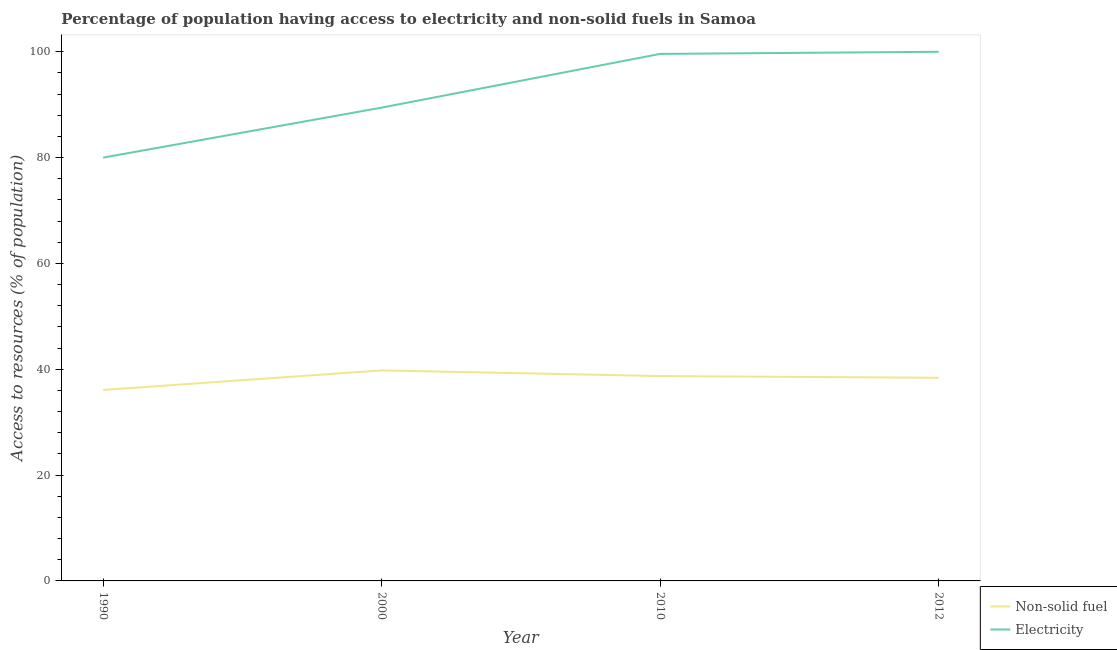Is the number of lines equal to the number of legend labels?
Offer a terse response. Yes. What is the percentage of population having access to non-solid fuel in 2012?
Provide a succinct answer. 38.39. Across all years, what is the maximum percentage of population having access to non-solid fuel?
Give a very brief answer. 39.78. Across all years, what is the minimum percentage of population having access to non-solid fuel?
Offer a very short reply. 36.09. In which year was the percentage of population having access to electricity maximum?
Provide a short and direct response. 2012. What is the total percentage of population having access to non-solid fuel in the graph?
Your answer should be compact. 152.99. What is the difference between the percentage of population having access to electricity in 1990 and that in 2000?
Your response must be concise. -9.45. What is the difference between the percentage of population having access to non-solid fuel in 2010 and the percentage of population having access to electricity in 2000?
Your response must be concise. -50.73. What is the average percentage of population having access to non-solid fuel per year?
Give a very brief answer. 38.25. In the year 2000, what is the difference between the percentage of population having access to non-solid fuel and percentage of population having access to electricity?
Keep it short and to the point. -49.66. In how many years, is the percentage of population having access to electricity greater than 92 %?
Ensure brevity in your answer.  2. What is the ratio of the percentage of population having access to non-solid fuel in 2010 to that in 2012?
Provide a succinct answer. 1.01. Is the percentage of population having access to electricity in 1990 less than that in 2012?
Offer a very short reply. Yes. Is the difference between the percentage of population having access to electricity in 2000 and 2012 greater than the difference between the percentage of population having access to non-solid fuel in 2000 and 2012?
Provide a short and direct response. No. What is the difference between the highest and the second highest percentage of population having access to non-solid fuel?
Make the answer very short. 1.07. What is the difference between the highest and the lowest percentage of population having access to non-solid fuel?
Offer a very short reply. 3.69. Is the sum of the percentage of population having access to electricity in 1990 and 2000 greater than the maximum percentage of population having access to non-solid fuel across all years?
Ensure brevity in your answer.  Yes. Is the percentage of population having access to electricity strictly greater than the percentage of population having access to non-solid fuel over the years?
Keep it short and to the point. Yes. Is the percentage of population having access to non-solid fuel strictly less than the percentage of population having access to electricity over the years?
Your answer should be compact. Yes. How many lines are there?
Your response must be concise. 2. How many years are there in the graph?
Give a very brief answer. 4. What is the difference between two consecutive major ticks on the Y-axis?
Your response must be concise. 20. Are the values on the major ticks of Y-axis written in scientific E-notation?
Offer a very short reply. No. Does the graph contain any zero values?
Give a very brief answer. No. Does the graph contain grids?
Your response must be concise. No. Where does the legend appear in the graph?
Your answer should be very brief. Bottom right. How many legend labels are there?
Provide a succinct answer. 2. What is the title of the graph?
Your response must be concise. Percentage of population having access to electricity and non-solid fuels in Samoa. What is the label or title of the Y-axis?
Your answer should be very brief. Access to resources (% of population). What is the Access to resources (% of population) in Non-solid fuel in 1990?
Provide a succinct answer. 36.09. What is the Access to resources (% of population) in Electricity in 1990?
Give a very brief answer. 80. What is the Access to resources (% of population) in Non-solid fuel in 2000?
Your response must be concise. 39.78. What is the Access to resources (% of population) in Electricity in 2000?
Your response must be concise. 89.45. What is the Access to resources (% of population) in Non-solid fuel in 2010?
Keep it short and to the point. 38.72. What is the Access to resources (% of population) of Electricity in 2010?
Offer a terse response. 99.6. What is the Access to resources (% of population) of Non-solid fuel in 2012?
Provide a succinct answer. 38.39. What is the Access to resources (% of population) in Electricity in 2012?
Give a very brief answer. 100. Across all years, what is the maximum Access to resources (% of population) of Non-solid fuel?
Give a very brief answer. 39.78. Across all years, what is the maximum Access to resources (% of population) of Electricity?
Give a very brief answer. 100. Across all years, what is the minimum Access to resources (% of population) of Non-solid fuel?
Make the answer very short. 36.09. What is the total Access to resources (% of population) of Non-solid fuel in the graph?
Ensure brevity in your answer.  152.99. What is the total Access to resources (% of population) of Electricity in the graph?
Provide a succinct answer. 369.05. What is the difference between the Access to resources (% of population) in Non-solid fuel in 1990 and that in 2000?
Your answer should be very brief. -3.69. What is the difference between the Access to resources (% of population) of Electricity in 1990 and that in 2000?
Your answer should be very brief. -9.45. What is the difference between the Access to resources (% of population) of Non-solid fuel in 1990 and that in 2010?
Make the answer very short. -2.62. What is the difference between the Access to resources (% of population) of Electricity in 1990 and that in 2010?
Offer a very short reply. -19.6. What is the difference between the Access to resources (% of population) in Non-solid fuel in 1990 and that in 2012?
Your answer should be very brief. -2.3. What is the difference between the Access to resources (% of population) in Non-solid fuel in 2000 and that in 2010?
Provide a succinct answer. 1.07. What is the difference between the Access to resources (% of population) in Electricity in 2000 and that in 2010?
Ensure brevity in your answer.  -10.15. What is the difference between the Access to resources (% of population) in Non-solid fuel in 2000 and that in 2012?
Your response must be concise. 1.39. What is the difference between the Access to resources (% of population) of Electricity in 2000 and that in 2012?
Offer a terse response. -10.55. What is the difference between the Access to resources (% of population) of Non-solid fuel in 2010 and that in 2012?
Ensure brevity in your answer.  0.33. What is the difference between the Access to resources (% of population) of Non-solid fuel in 1990 and the Access to resources (% of population) of Electricity in 2000?
Offer a very short reply. -53.35. What is the difference between the Access to resources (% of population) in Non-solid fuel in 1990 and the Access to resources (% of population) in Electricity in 2010?
Make the answer very short. -63.51. What is the difference between the Access to resources (% of population) of Non-solid fuel in 1990 and the Access to resources (% of population) of Electricity in 2012?
Offer a terse response. -63.91. What is the difference between the Access to resources (% of population) of Non-solid fuel in 2000 and the Access to resources (% of population) of Electricity in 2010?
Ensure brevity in your answer.  -59.82. What is the difference between the Access to resources (% of population) in Non-solid fuel in 2000 and the Access to resources (% of population) in Electricity in 2012?
Your answer should be very brief. -60.22. What is the difference between the Access to resources (% of population) of Non-solid fuel in 2010 and the Access to resources (% of population) of Electricity in 2012?
Provide a short and direct response. -61.28. What is the average Access to resources (% of population) in Non-solid fuel per year?
Offer a very short reply. 38.25. What is the average Access to resources (% of population) of Electricity per year?
Offer a very short reply. 92.26. In the year 1990, what is the difference between the Access to resources (% of population) in Non-solid fuel and Access to resources (% of population) in Electricity?
Your answer should be very brief. -43.91. In the year 2000, what is the difference between the Access to resources (% of population) in Non-solid fuel and Access to resources (% of population) in Electricity?
Your answer should be very brief. -49.66. In the year 2010, what is the difference between the Access to resources (% of population) of Non-solid fuel and Access to resources (% of population) of Electricity?
Provide a short and direct response. -60.88. In the year 2012, what is the difference between the Access to resources (% of population) in Non-solid fuel and Access to resources (% of population) in Electricity?
Keep it short and to the point. -61.61. What is the ratio of the Access to resources (% of population) in Non-solid fuel in 1990 to that in 2000?
Keep it short and to the point. 0.91. What is the ratio of the Access to resources (% of population) of Electricity in 1990 to that in 2000?
Provide a succinct answer. 0.89. What is the ratio of the Access to resources (% of population) of Non-solid fuel in 1990 to that in 2010?
Make the answer very short. 0.93. What is the ratio of the Access to resources (% of population) of Electricity in 1990 to that in 2010?
Your answer should be very brief. 0.8. What is the ratio of the Access to resources (% of population) in Non-solid fuel in 1990 to that in 2012?
Ensure brevity in your answer.  0.94. What is the ratio of the Access to resources (% of population) in Non-solid fuel in 2000 to that in 2010?
Offer a very short reply. 1.03. What is the ratio of the Access to resources (% of population) in Electricity in 2000 to that in 2010?
Give a very brief answer. 0.9. What is the ratio of the Access to resources (% of population) of Non-solid fuel in 2000 to that in 2012?
Provide a succinct answer. 1.04. What is the ratio of the Access to resources (% of population) in Electricity in 2000 to that in 2012?
Ensure brevity in your answer.  0.89. What is the ratio of the Access to resources (% of population) of Non-solid fuel in 2010 to that in 2012?
Ensure brevity in your answer.  1.01. What is the difference between the highest and the second highest Access to resources (% of population) in Non-solid fuel?
Your response must be concise. 1.07. What is the difference between the highest and the second highest Access to resources (% of population) in Electricity?
Provide a short and direct response. 0.4. What is the difference between the highest and the lowest Access to resources (% of population) in Non-solid fuel?
Provide a succinct answer. 3.69. What is the difference between the highest and the lowest Access to resources (% of population) of Electricity?
Your answer should be very brief. 20. 